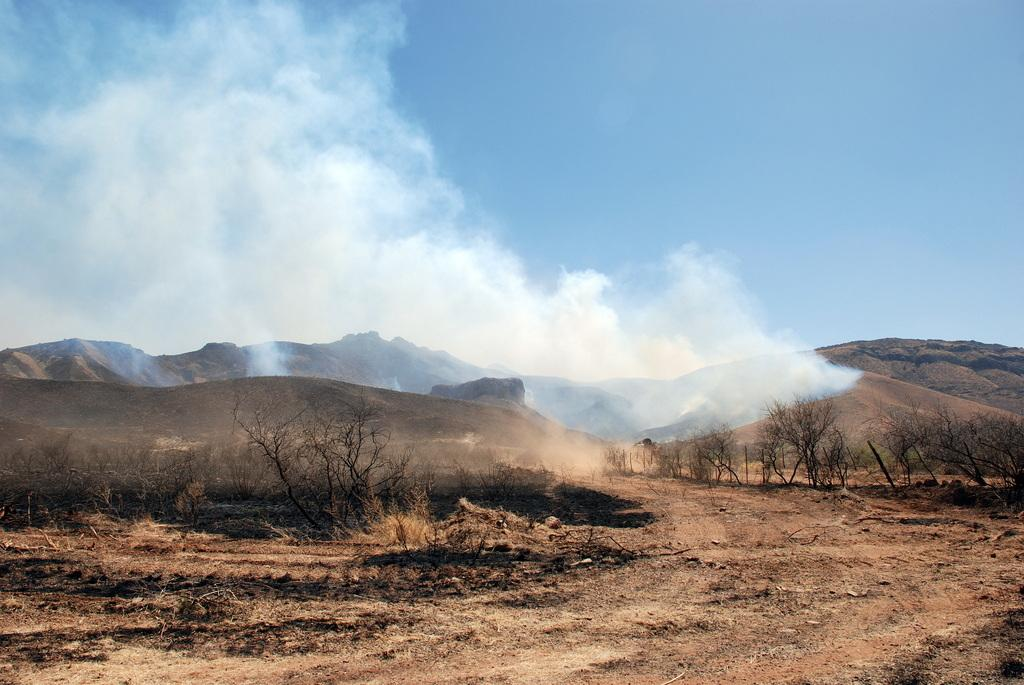What type of natural features are located in the middle of the image? There are trees and mountains in the middle of the image. What is visible at the top of the image? The sky is visible at the top of the image. What can be seen coming from the trees or mountains in the image? There is smoke in the middle of the image. Who is the manager of the street seen in the image? There is no street present in the image, so there is no manager to discuss. 